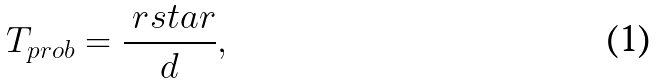Convert formula to latex. <formula><loc_0><loc_0><loc_500><loc_500>T _ { p r o b } = \frac { \ r s t a r } { d } ,</formula> 